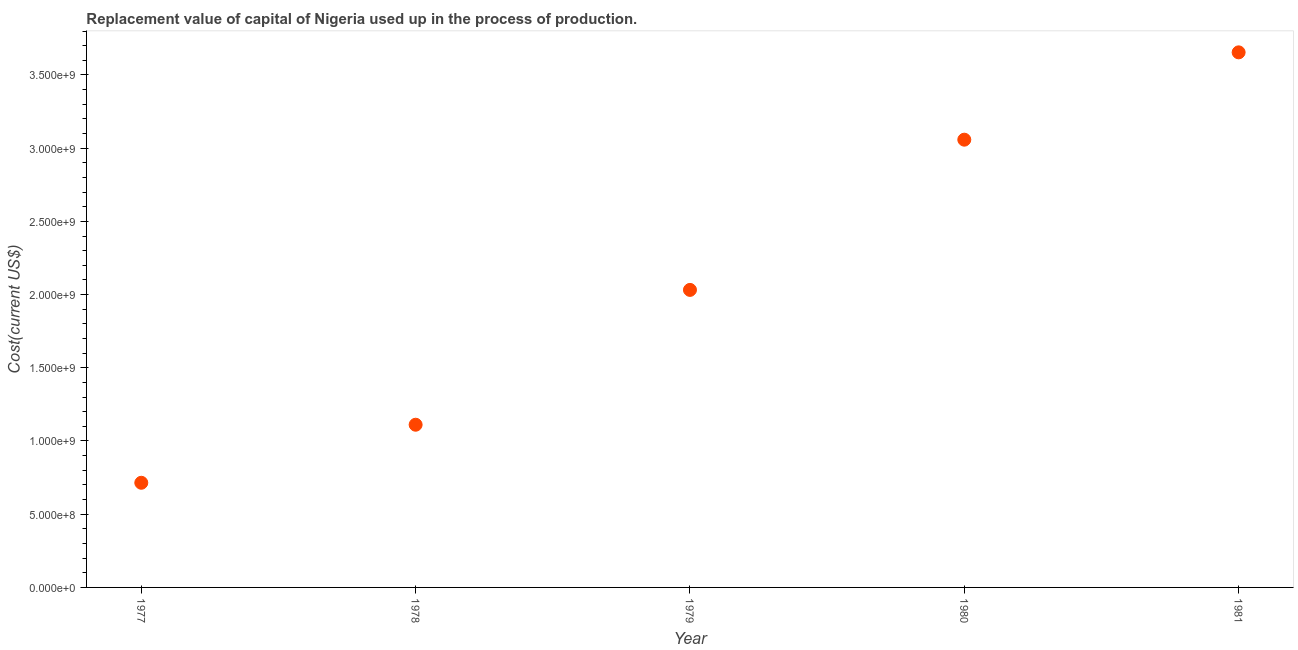What is the consumption of fixed capital in 1979?
Keep it short and to the point. 2.03e+09. Across all years, what is the maximum consumption of fixed capital?
Give a very brief answer. 3.65e+09. Across all years, what is the minimum consumption of fixed capital?
Ensure brevity in your answer.  7.15e+08. In which year was the consumption of fixed capital minimum?
Offer a very short reply. 1977. What is the sum of the consumption of fixed capital?
Keep it short and to the point. 1.06e+1. What is the difference between the consumption of fixed capital in 1978 and 1979?
Offer a very short reply. -9.21e+08. What is the average consumption of fixed capital per year?
Offer a very short reply. 2.11e+09. What is the median consumption of fixed capital?
Give a very brief answer. 2.03e+09. Do a majority of the years between 1980 and 1979 (inclusive) have consumption of fixed capital greater than 3700000000 US$?
Provide a succinct answer. No. What is the ratio of the consumption of fixed capital in 1977 to that in 1978?
Your answer should be compact. 0.64. Is the consumption of fixed capital in 1978 less than that in 1981?
Your response must be concise. Yes. What is the difference between the highest and the second highest consumption of fixed capital?
Your response must be concise. 5.96e+08. What is the difference between the highest and the lowest consumption of fixed capital?
Ensure brevity in your answer.  2.94e+09. Does the consumption of fixed capital monotonically increase over the years?
Your answer should be very brief. Yes. What is the difference between two consecutive major ticks on the Y-axis?
Provide a short and direct response. 5.00e+08. Are the values on the major ticks of Y-axis written in scientific E-notation?
Make the answer very short. Yes. Does the graph contain any zero values?
Offer a terse response. No. Does the graph contain grids?
Provide a short and direct response. No. What is the title of the graph?
Provide a succinct answer. Replacement value of capital of Nigeria used up in the process of production. What is the label or title of the Y-axis?
Provide a short and direct response. Cost(current US$). What is the Cost(current US$) in 1977?
Offer a very short reply. 7.15e+08. What is the Cost(current US$) in 1978?
Make the answer very short. 1.11e+09. What is the Cost(current US$) in 1979?
Ensure brevity in your answer.  2.03e+09. What is the Cost(current US$) in 1980?
Provide a succinct answer. 3.06e+09. What is the Cost(current US$) in 1981?
Provide a short and direct response. 3.65e+09. What is the difference between the Cost(current US$) in 1977 and 1978?
Make the answer very short. -3.96e+08. What is the difference between the Cost(current US$) in 1977 and 1979?
Provide a short and direct response. -1.32e+09. What is the difference between the Cost(current US$) in 1977 and 1980?
Your answer should be very brief. -2.34e+09. What is the difference between the Cost(current US$) in 1977 and 1981?
Your answer should be compact. -2.94e+09. What is the difference between the Cost(current US$) in 1978 and 1979?
Offer a very short reply. -9.21e+08. What is the difference between the Cost(current US$) in 1978 and 1980?
Keep it short and to the point. -1.95e+09. What is the difference between the Cost(current US$) in 1978 and 1981?
Your answer should be very brief. -2.54e+09. What is the difference between the Cost(current US$) in 1979 and 1980?
Your response must be concise. -1.03e+09. What is the difference between the Cost(current US$) in 1979 and 1981?
Keep it short and to the point. -1.62e+09. What is the difference between the Cost(current US$) in 1980 and 1981?
Offer a very short reply. -5.96e+08. What is the ratio of the Cost(current US$) in 1977 to that in 1978?
Make the answer very short. 0.64. What is the ratio of the Cost(current US$) in 1977 to that in 1979?
Your answer should be compact. 0.35. What is the ratio of the Cost(current US$) in 1977 to that in 1980?
Ensure brevity in your answer.  0.23. What is the ratio of the Cost(current US$) in 1977 to that in 1981?
Provide a short and direct response. 0.2. What is the ratio of the Cost(current US$) in 1978 to that in 1979?
Provide a succinct answer. 0.55. What is the ratio of the Cost(current US$) in 1978 to that in 1980?
Make the answer very short. 0.36. What is the ratio of the Cost(current US$) in 1978 to that in 1981?
Your answer should be compact. 0.3. What is the ratio of the Cost(current US$) in 1979 to that in 1980?
Offer a terse response. 0.66. What is the ratio of the Cost(current US$) in 1979 to that in 1981?
Offer a terse response. 0.56. What is the ratio of the Cost(current US$) in 1980 to that in 1981?
Your answer should be very brief. 0.84. 